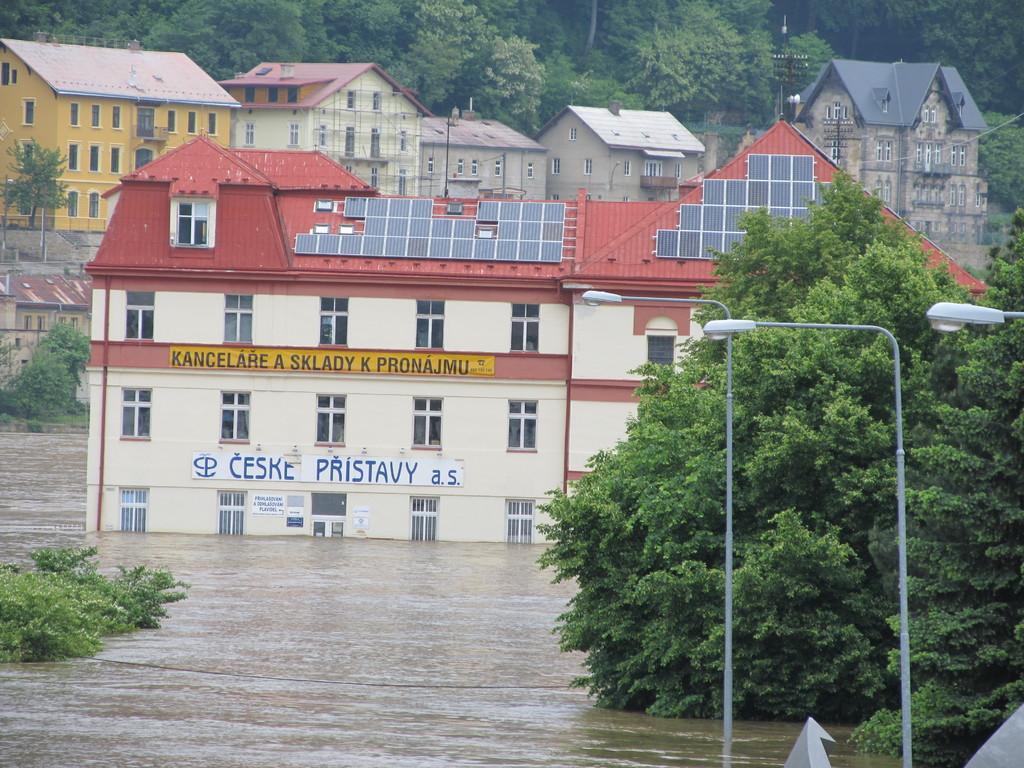Describe this image in one or two sentences. In this image in the center there is water and there is a building. On the right side there are poles, trees. On the left side there are trees. In the background there are buildings and there are trees. In the front on the building there is some text written on the wall. 